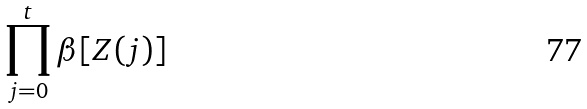Convert formula to latex. <formula><loc_0><loc_0><loc_500><loc_500>\prod _ { j = 0 } ^ { t } \beta [ Z ( j ) ]</formula> 